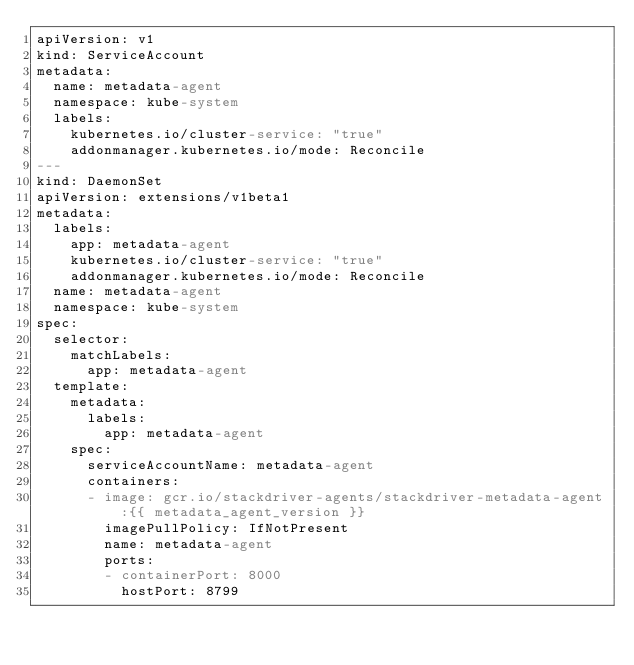Convert code to text. <code><loc_0><loc_0><loc_500><loc_500><_YAML_>apiVersion: v1
kind: ServiceAccount
metadata:
  name: metadata-agent
  namespace: kube-system
  labels:
    kubernetes.io/cluster-service: "true"
    addonmanager.kubernetes.io/mode: Reconcile
---
kind: DaemonSet
apiVersion: extensions/v1beta1
metadata:
  labels:
    app: metadata-agent
    kubernetes.io/cluster-service: "true"
    addonmanager.kubernetes.io/mode: Reconcile
  name: metadata-agent
  namespace: kube-system
spec:
  selector:
    matchLabels:
      app: metadata-agent
  template:
    metadata:
      labels:
        app: metadata-agent
    spec:
      serviceAccountName: metadata-agent
      containers:
      - image: gcr.io/stackdriver-agents/stackdriver-metadata-agent:{{ metadata_agent_version }}
        imagePullPolicy: IfNotPresent
        name: metadata-agent
        ports:
        - containerPort: 8000
          hostPort: 8799</code> 